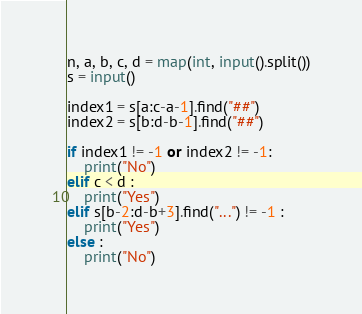Convert code to text. <code><loc_0><loc_0><loc_500><loc_500><_Python_>n, a, b, c, d = map(int, input().split())
s = input()
 
index1 = s[a:c-a-1].find("##")
index2 = s[b:d-b-1].find("##")
 
if index1 != -1 or index2 != -1:
	print("No")
elif c < d :
	print("Yes")
elif s[b-2:d-b+3].find("...") != -1 : 
	print("Yes")
else :
	print("No")</code> 